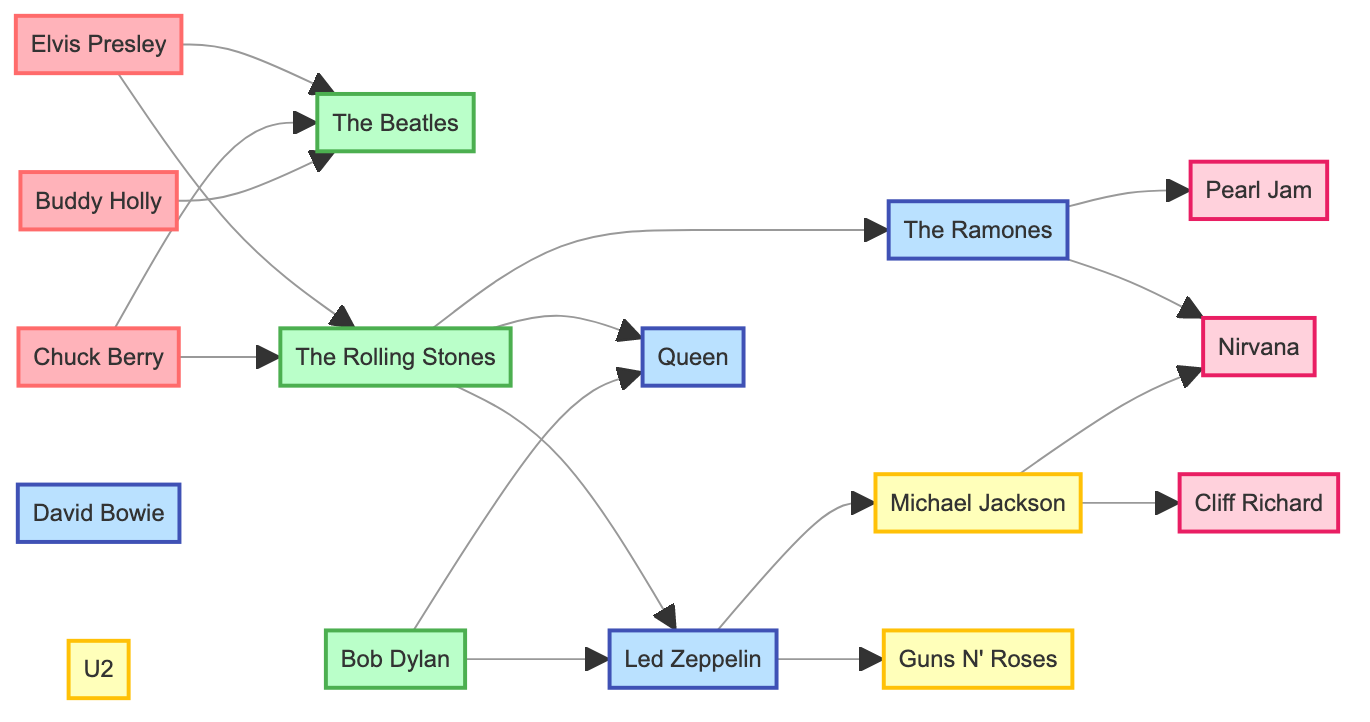What are the total number of nodes in the diagram? The diagram lists a variety of musicians and bands categorized by decade. By counting all the unique entries in the "nodes" section, we find that there are 16 distinct nodes present.
Answer: 16 Who is connected to The Beatles? The edges connecting to The Beatles are from Elvis Presley, Chuck Berry, and Buddy Holly. This means that all three musicians listed influence The Beatles in some capacity according to the diagram.
Answer: Elvis Presley, Chuck Berry, Buddy Holly Which musician from the 1960s influences Cliff Richard? According to the diagram, the only musician connected to Cliff Richard is Michael Jackson, who is positioned in the 1980s as a connection. This shows a directed influence from the 1980s back to the 1990s.
Answer: Michael Jackson How many musicians from the 1970s influence Nirvana? By examining the diagram, Nirvana has a connection to two musicians from the 1970s: The Ramones and Pearl Jam. This can be observed from the edges leading towards Nirvana from these two nodes.
Answer: 2 Which musicians from the 1960s have connections to Led Zeppelin? In the diagram, Led Zeppelin is influenced by Bob Dylan and The Rolling Stones, which indicates their significance in shaping the sound or style of Led Zeppelin.
Answer: Bob Dylan, The Rolling Stones What is the direct connection between The Rolling Stones and Queen? The diagram shows that The Rolling Stones influence Queen directly. There is a visible edge leading from The Rolling Stones that connects to Queen, establishing this direct influence relationship.
Answer: The Rolling Stones How many edges are connected to Elvis Presley? By reviewing the connections in the diagram, Elvis Presley has a total of two edges connecting him to The Beatles and The Rolling Stones. This indicates his influence on both of these key bands in the subsequent decades.
Answer: 2 Which group has the most connections in the diagram? The group represented by The Rolling Stones has the widest array of connections, linking it to The Beatles, Led Zeppelin, The Ramones, and Queen. Counting these edges reveals The Rolling Stones as the most interconnected node.
Answer: The Rolling Stones Which decade does Cliff Richard belong to? The diagram categorizes Cliff Richard distinctly in the 1990s; this is clearly labeled in the "group" field for Cliff Richard in the nodes section of the data.
Answer: 1990s 